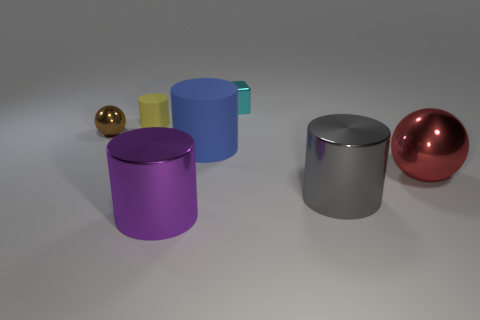Subtract all big gray metal cylinders. How many cylinders are left? 3 Subtract all gray cylinders. How many cylinders are left? 3 Subtract 2 cylinders. How many cylinders are left? 2 Subtract all brown cylinders. Subtract all cyan spheres. How many cylinders are left? 4 Add 1 matte objects. How many objects exist? 8 Subtract all cubes. How many objects are left? 6 Subtract all red things. Subtract all small yellow things. How many objects are left? 5 Add 6 big things. How many big things are left? 10 Add 2 brown balls. How many brown balls exist? 3 Subtract 0 yellow spheres. How many objects are left? 7 